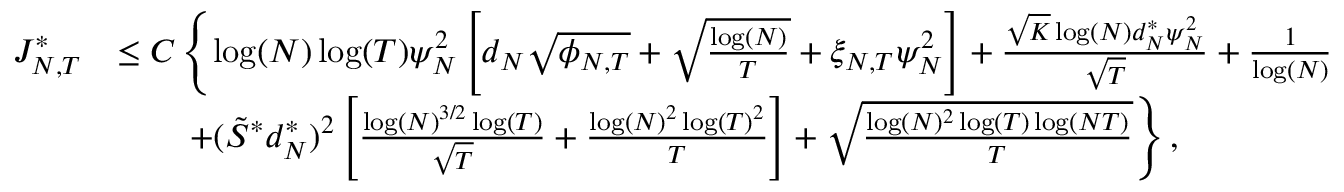<formula> <loc_0><loc_0><loc_500><loc_500>\begin{array} { r l } { { J _ { N , T } ^ { * } } } & { \leq C \left \{ \log ( N ) \log ( T ) \psi _ { N } ^ { 2 } \left [ d _ { N } \sqrt { \phi _ { N , T } } + \sqrt { \frac { \log ( N ) } { T } } + \xi _ { N , T } \psi _ { N } ^ { 2 } \right ] + \frac { \sqrt { K } \log ( N ) d _ { N } ^ { * } \psi _ { N } ^ { 2 } } { \sqrt { T } } + \frac { 1 } { \log ( N ) } } \\ & { \quad + ( \tilde { S } ^ { * } d _ { N } ^ { * } ) ^ { 2 } \left [ \frac { \log ( N ) ^ { 3 / 2 } \log ( T ) } { \sqrt { T } } + \frac { \log ( N ) ^ { 2 } \log ( T ) ^ { 2 } } { T } \right ] + \sqrt { \frac { \log ( N ) ^ { 2 } \log ( T ) \log ( N T ) } { T } } \right \} , } \end{array}</formula> 